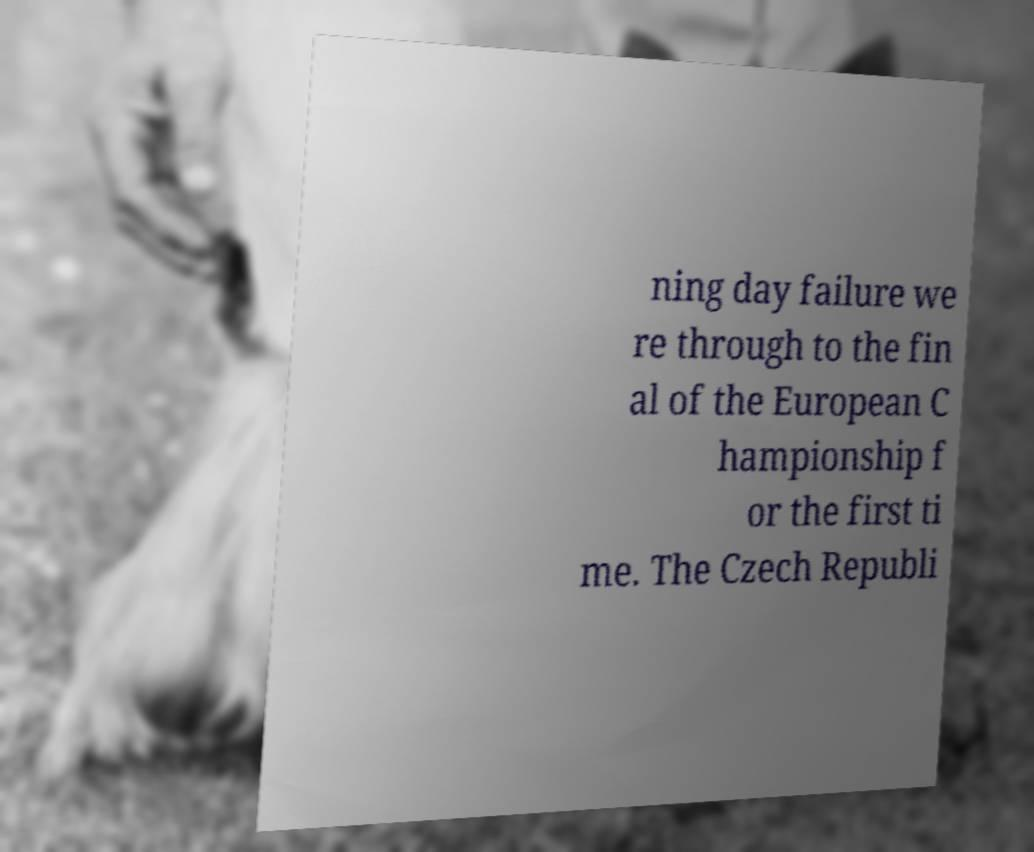Can you read and provide the text displayed in the image?This photo seems to have some interesting text. Can you extract and type it out for me? ning day failure we re through to the fin al of the European C hampionship f or the first ti me. The Czech Republi 